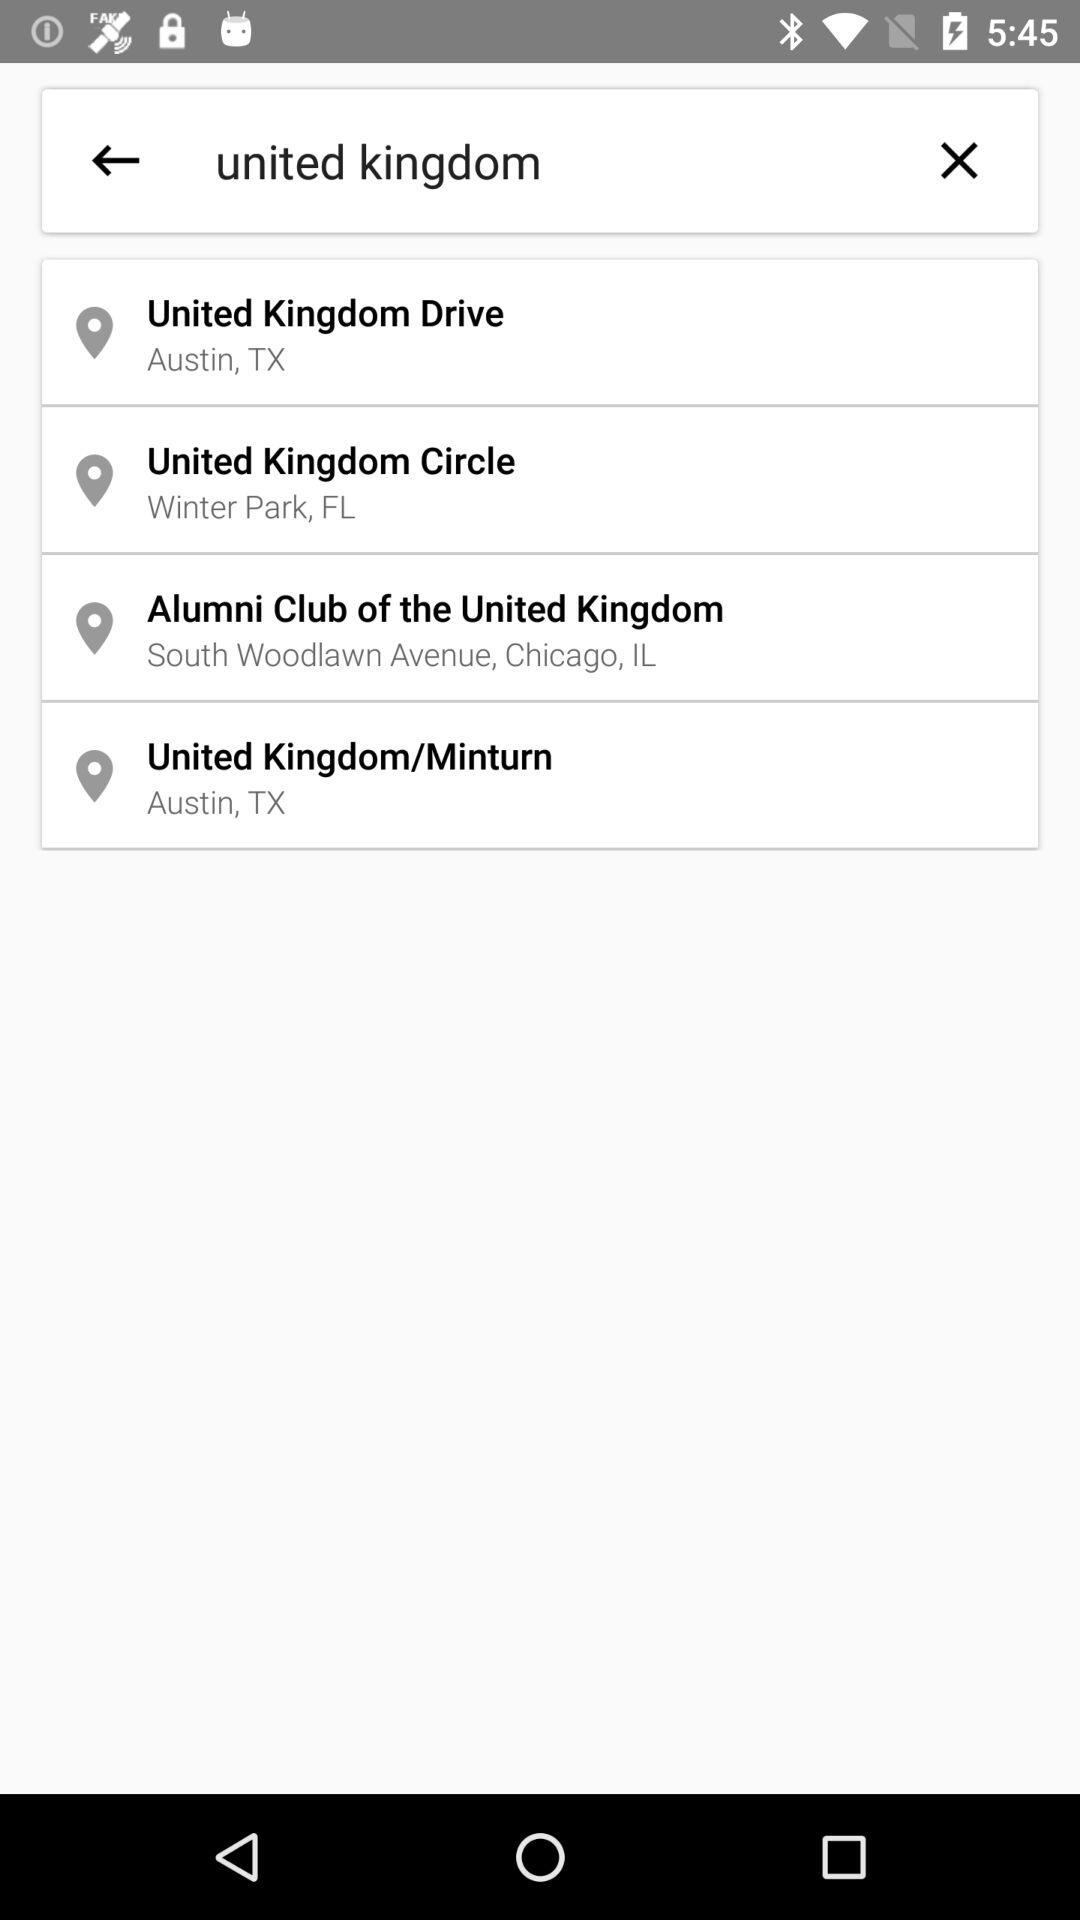What is the location of the United Kingdom Drive? The location is Austin, TX. 